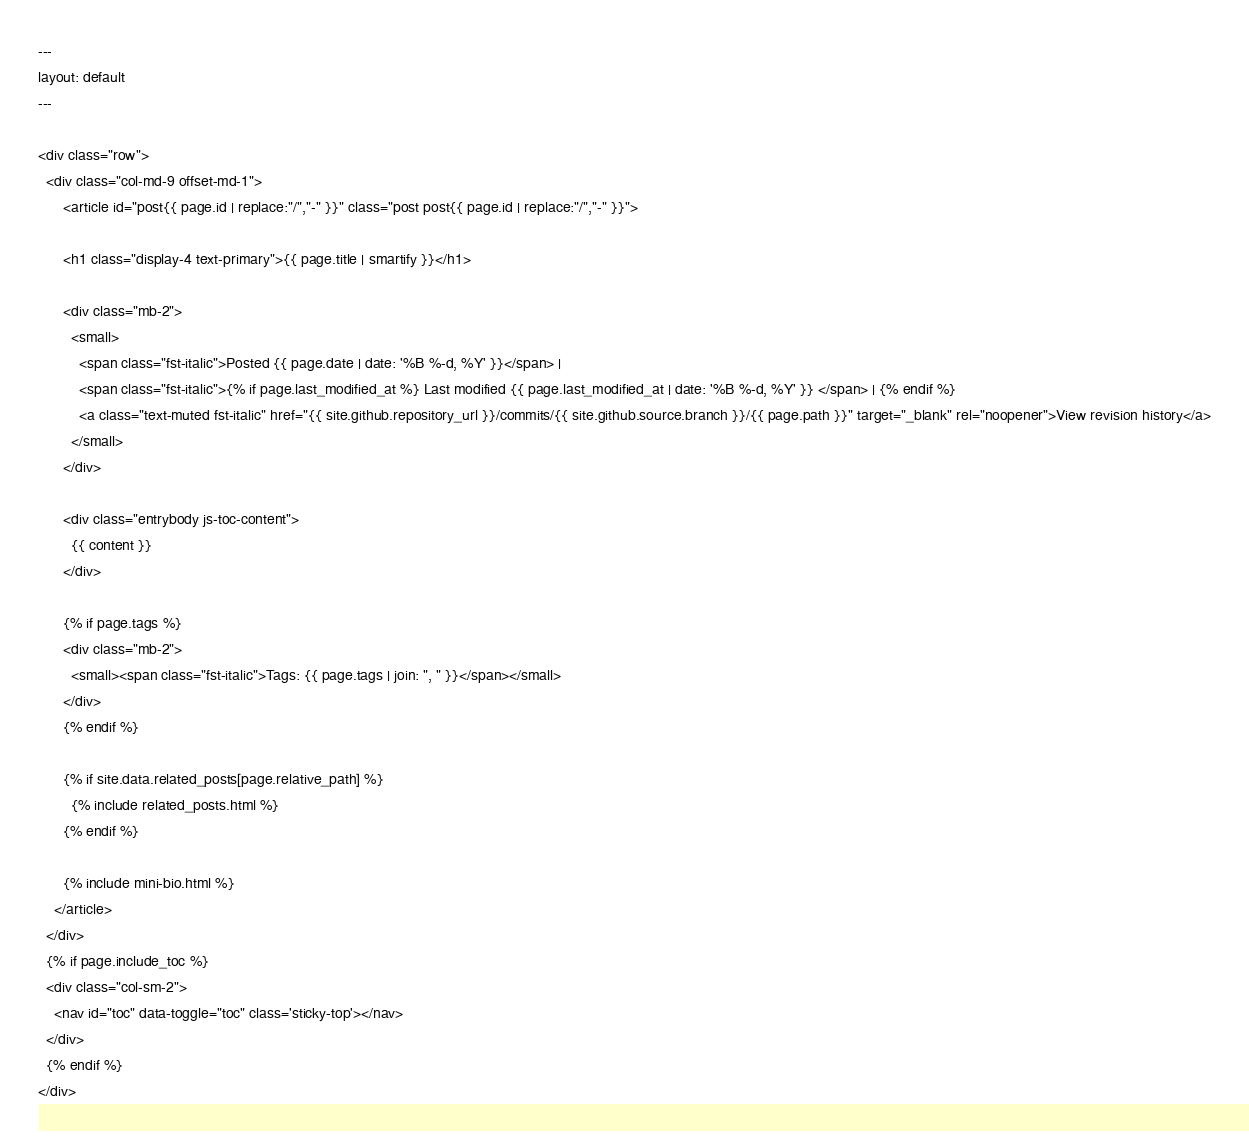<code> <loc_0><loc_0><loc_500><loc_500><_HTML_>---
layout: default
---

<div class="row">
  <div class="col-md-9 offset-md-1">
      <article id="post{{ page.id | replace:"/","-" }}" class="post post{{ page.id | replace:"/","-" }}">

      <h1 class="display-4 text-primary">{{ page.title | smartify }}</h1>

      <div class="mb-2">
        <small>
          <span class="fst-italic">Posted {{ page.date | date: '%B %-d, %Y' }}</span> |
          <span class="fst-italic">{% if page.last_modified_at %} Last modified {{ page.last_modified_at | date: '%B %-d, %Y' }} </span> | {% endif %}
          <a class="text-muted fst-italic" href="{{ site.github.repository_url }}/commits/{{ site.github.source.branch }}/{{ page.path }}" target="_blank" rel="noopener">View revision history</a>
        </small>
      </div>

      <div class="entrybody js-toc-content">
        {{ content }}
      </div>

      {% if page.tags %}
      <div class="mb-2">
        <small><span class="fst-italic">Tags: {{ page.tags | join: ", " }}</span></small>
      </div>
      {% endif %}

      {% if site.data.related_posts[page.relative_path] %}
        {% include related_posts.html %}
      {% endif %}

      {% include mini-bio.html %}
    </article>
  </div>
  {% if page.include_toc %}
  <div class="col-sm-2">
    <nav id="toc" data-toggle="toc" class='sticky-top'></nav>
  </div>
  {% endif %}
</div>
</code> 